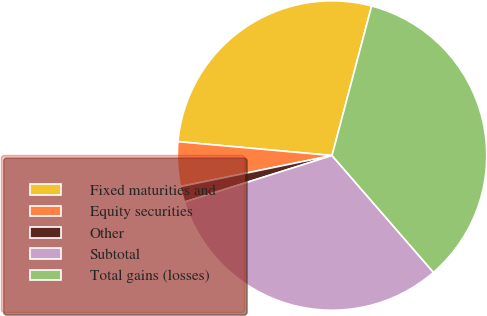<chart> <loc_0><loc_0><loc_500><loc_500><pie_chart><fcel>Fixed maturities and<fcel>Equity securities<fcel>Other<fcel>Subtotal<fcel>Total gains (losses)<nl><fcel>27.69%<fcel>4.64%<fcel>1.65%<fcel>31.52%<fcel>34.5%<nl></chart> 